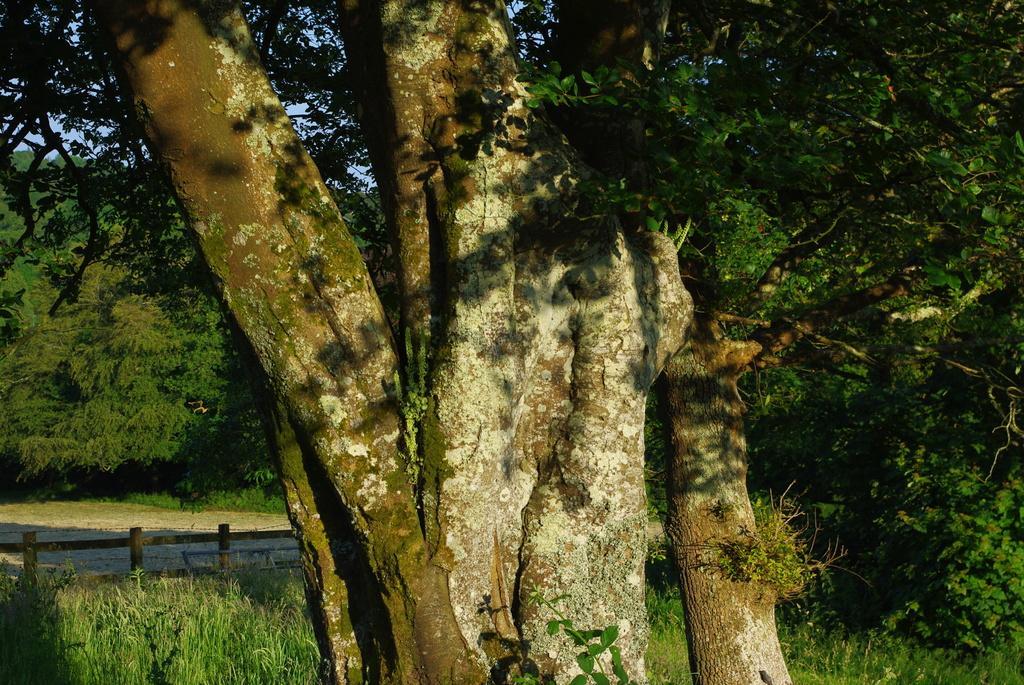Please provide a concise description of this image. In the image in the center, we can see the sky, trees, plants, grass and fence. 